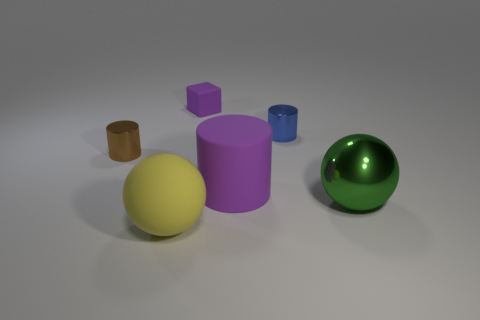Add 1 small cubes. How many objects exist? 7 Subtract all spheres. How many objects are left? 4 Add 2 brown cylinders. How many brown cylinders exist? 3 Subtract 1 purple cylinders. How many objects are left? 5 Subtract all yellow rubber cylinders. Subtract all large yellow matte things. How many objects are left? 5 Add 3 big yellow spheres. How many big yellow spheres are left? 4 